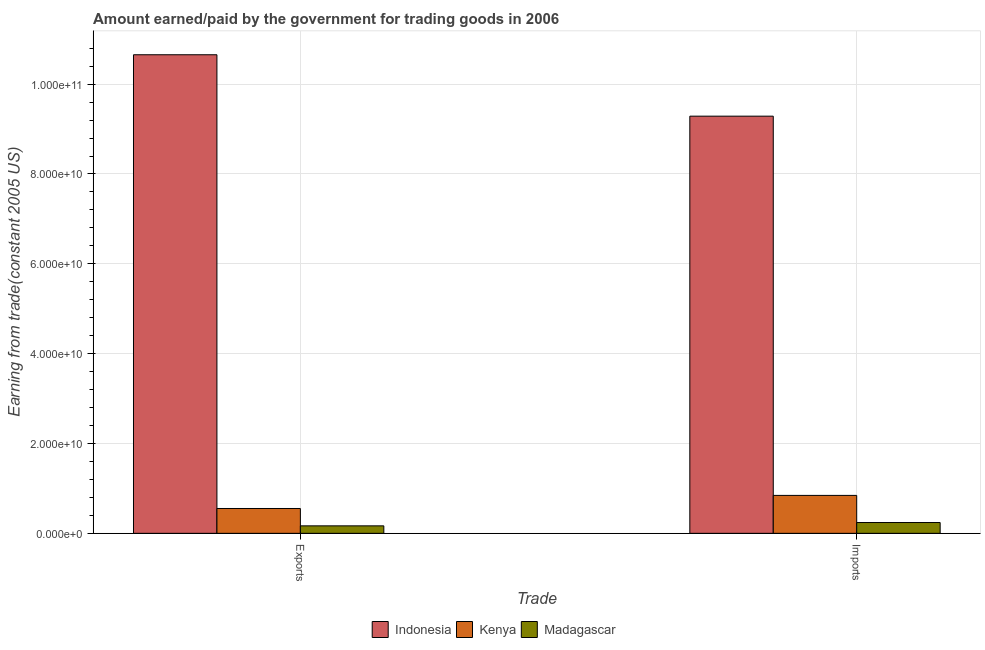How many different coloured bars are there?
Provide a short and direct response. 3. How many groups of bars are there?
Offer a very short reply. 2. Are the number of bars per tick equal to the number of legend labels?
Your answer should be very brief. Yes. How many bars are there on the 1st tick from the left?
Your response must be concise. 3. What is the label of the 2nd group of bars from the left?
Offer a terse response. Imports. What is the amount earned from exports in Kenya?
Your answer should be compact. 5.53e+09. Across all countries, what is the maximum amount earned from exports?
Your response must be concise. 1.07e+11. Across all countries, what is the minimum amount earned from exports?
Provide a succinct answer. 1.67e+09. In which country was the amount paid for imports minimum?
Keep it short and to the point. Madagascar. What is the total amount earned from exports in the graph?
Ensure brevity in your answer.  1.14e+11. What is the difference between the amount earned from exports in Madagascar and that in Kenya?
Provide a short and direct response. -3.86e+09. What is the difference between the amount earned from exports in Madagascar and the amount paid for imports in Kenya?
Keep it short and to the point. -6.78e+09. What is the average amount earned from exports per country?
Give a very brief answer. 3.79e+1. What is the difference between the amount earned from exports and amount paid for imports in Indonesia?
Give a very brief answer. 1.37e+1. What is the ratio of the amount earned from exports in Kenya to that in Madagascar?
Give a very brief answer. 3.32. In how many countries, is the amount paid for imports greater than the average amount paid for imports taken over all countries?
Provide a succinct answer. 1. What does the 3rd bar from the left in Exports represents?
Make the answer very short. Madagascar. What does the 2nd bar from the right in Imports represents?
Your response must be concise. Kenya. How many bars are there?
Offer a terse response. 6. How many countries are there in the graph?
Keep it short and to the point. 3. What is the difference between two consecutive major ticks on the Y-axis?
Make the answer very short. 2.00e+1. Does the graph contain grids?
Your answer should be compact. Yes. What is the title of the graph?
Your answer should be very brief. Amount earned/paid by the government for trading goods in 2006. What is the label or title of the X-axis?
Offer a terse response. Trade. What is the label or title of the Y-axis?
Give a very brief answer. Earning from trade(constant 2005 US). What is the Earning from trade(constant 2005 US) in Indonesia in Exports?
Give a very brief answer. 1.07e+11. What is the Earning from trade(constant 2005 US) in Kenya in Exports?
Your response must be concise. 5.53e+09. What is the Earning from trade(constant 2005 US) in Madagascar in Exports?
Provide a short and direct response. 1.67e+09. What is the Earning from trade(constant 2005 US) in Indonesia in Imports?
Your response must be concise. 9.29e+1. What is the Earning from trade(constant 2005 US) of Kenya in Imports?
Provide a short and direct response. 8.45e+09. What is the Earning from trade(constant 2005 US) in Madagascar in Imports?
Keep it short and to the point. 2.41e+09. Across all Trade, what is the maximum Earning from trade(constant 2005 US) of Indonesia?
Provide a succinct answer. 1.07e+11. Across all Trade, what is the maximum Earning from trade(constant 2005 US) of Kenya?
Offer a very short reply. 8.45e+09. Across all Trade, what is the maximum Earning from trade(constant 2005 US) in Madagascar?
Offer a very short reply. 2.41e+09. Across all Trade, what is the minimum Earning from trade(constant 2005 US) in Indonesia?
Your answer should be very brief. 9.29e+1. Across all Trade, what is the minimum Earning from trade(constant 2005 US) in Kenya?
Your response must be concise. 5.53e+09. Across all Trade, what is the minimum Earning from trade(constant 2005 US) in Madagascar?
Give a very brief answer. 1.67e+09. What is the total Earning from trade(constant 2005 US) in Indonesia in the graph?
Give a very brief answer. 1.99e+11. What is the total Earning from trade(constant 2005 US) in Kenya in the graph?
Provide a short and direct response. 1.40e+1. What is the total Earning from trade(constant 2005 US) of Madagascar in the graph?
Give a very brief answer. 4.07e+09. What is the difference between the Earning from trade(constant 2005 US) of Indonesia in Exports and that in Imports?
Keep it short and to the point. 1.37e+1. What is the difference between the Earning from trade(constant 2005 US) of Kenya in Exports and that in Imports?
Ensure brevity in your answer.  -2.92e+09. What is the difference between the Earning from trade(constant 2005 US) of Madagascar in Exports and that in Imports?
Provide a short and direct response. -7.41e+08. What is the difference between the Earning from trade(constant 2005 US) in Indonesia in Exports and the Earning from trade(constant 2005 US) in Kenya in Imports?
Offer a very short reply. 9.81e+1. What is the difference between the Earning from trade(constant 2005 US) in Indonesia in Exports and the Earning from trade(constant 2005 US) in Madagascar in Imports?
Your answer should be compact. 1.04e+11. What is the difference between the Earning from trade(constant 2005 US) of Kenya in Exports and the Earning from trade(constant 2005 US) of Madagascar in Imports?
Keep it short and to the point. 3.12e+09. What is the average Earning from trade(constant 2005 US) in Indonesia per Trade?
Ensure brevity in your answer.  9.97e+1. What is the average Earning from trade(constant 2005 US) in Kenya per Trade?
Offer a very short reply. 6.99e+09. What is the average Earning from trade(constant 2005 US) in Madagascar per Trade?
Offer a very short reply. 2.04e+09. What is the difference between the Earning from trade(constant 2005 US) of Indonesia and Earning from trade(constant 2005 US) of Kenya in Exports?
Keep it short and to the point. 1.01e+11. What is the difference between the Earning from trade(constant 2005 US) of Indonesia and Earning from trade(constant 2005 US) of Madagascar in Exports?
Ensure brevity in your answer.  1.05e+11. What is the difference between the Earning from trade(constant 2005 US) in Kenya and Earning from trade(constant 2005 US) in Madagascar in Exports?
Ensure brevity in your answer.  3.86e+09. What is the difference between the Earning from trade(constant 2005 US) in Indonesia and Earning from trade(constant 2005 US) in Kenya in Imports?
Your answer should be very brief. 8.44e+1. What is the difference between the Earning from trade(constant 2005 US) in Indonesia and Earning from trade(constant 2005 US) in Madagascar in Imports?
Provide a short and direct response. 9.05e+1. What is the difference between the Earning from trade(constant 2005 US) in Kenya and Earning from trade(constant 2005 US) in Madagascar in Imports?
Offer a very short reply. 6.04e+09. What is the ratio of the Earning from trade(constant 2005 US) in Indonesia in Exports to that in Imports?
Make the answer very short. 1.15. What is the ratio of the Earning from trade(constant 2005 US) of Kenya in Exports to that in Imports?
Your answer should be very brief. 0.65. What is the ratio of the Earning from trade(constant 2005 US) of Madagascar in Exports to that in Imports?
Your answer should be very brief. 0.69. What is the difference between the highest and the second highest Earning from trade(constant 2005 US) of Indonesia?
Provide a succinct answer. 1.37e+1. What is the difference between the highest and the second highest Earning from trade(constant 2005 US) of Kenya?
Your response must be concise. 2.92e+09. What is the difference between the highest and the second highest Earning from trade(constant 2005 US) of Madagascar?
Your answer should be very brief. 7.41e+08. What is the difference between the highest and the lowest Earning from trade(constant 2005 US) in Indonesia?
Your answer should be very brief. 1.37e+1. What is the difference between the highest and the lowest Earning from trade(constant 2005 US) of Kenya?
Your answer should be very brief. 2.92e+09. What is the difference between the highest and the lowest Earning from trade(constant 2005 US) of Madagascar?
Provide a succinct answer. 7.41e+08. 